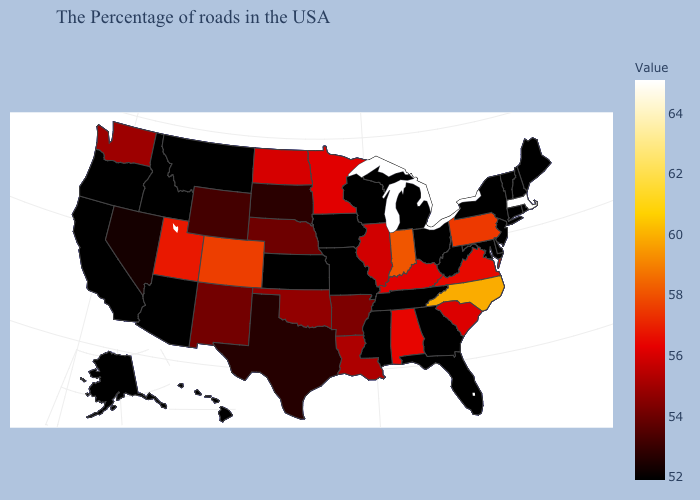Does Michigan have the lowest value in the USA?
Give a very brief answer. Yes. Does Colorado have the lowest value in the West?
Give a very brief answer. No. Among the states that border Michigan , which have the lowest value?
Give a very brief answer. Ohio, Wisconsin. Which states have the lowest value in the Northeast?
Answer briefly. Maine, Rhode Island, New Hampshire, Vermont, Connecticut, New York, New Jersey. Does the map have missing data?
Short answer required. No. Which states have the highest value in the USA?
Write a very short answer. Massachusetts. 